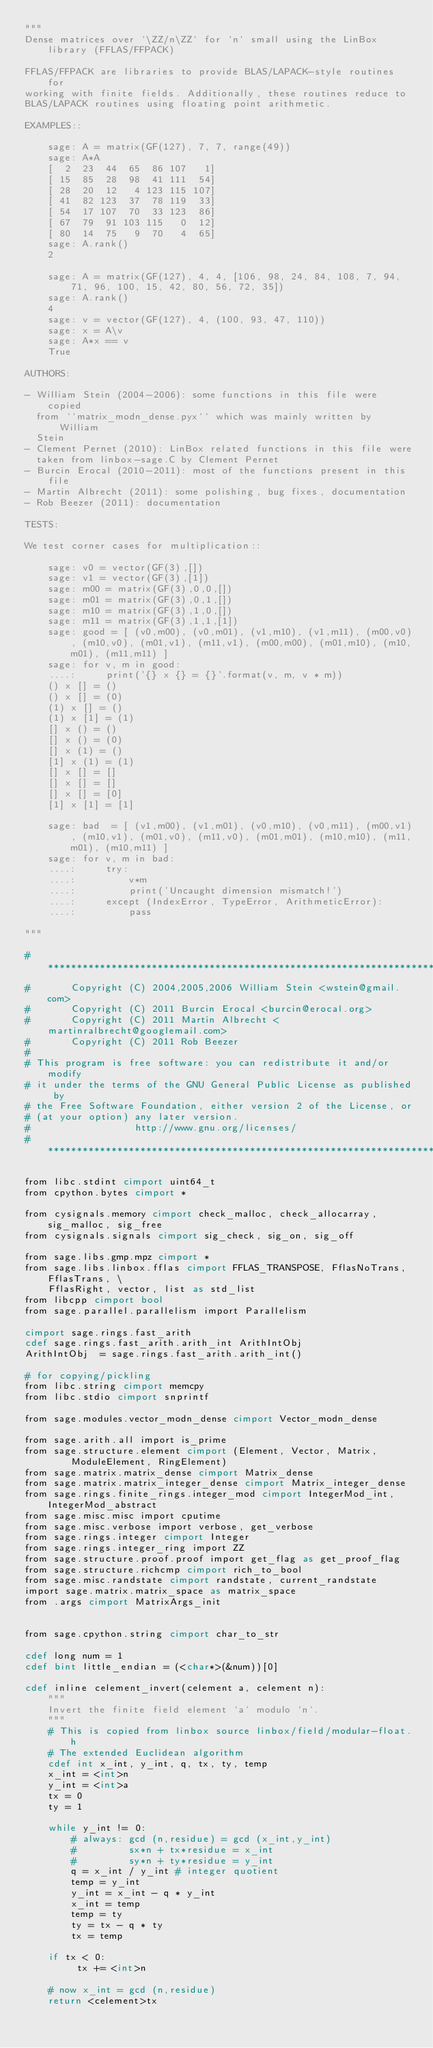<code> <loc_0><loc_0><loc_500><loc_500><_Cython_>"""
Dense matrices over `\ZZ/n\ZZ` for `n` small using the LinBox library (FFLAS/FFPACK)

FFLAS/FFPACK are libraries to provide BLAS/LAPACK-style routines for
working with finite fields. Additionally, these routines reduce to
BLAS/LAPACK routines using floating point arithmetic.

EXAMPLES::

    sage: A = matrix(GF(127), 7, 7, range(49))
    sage: A*A
    [  2  23  44  65  86 107   1]
    [ 15  85  28  98  41 111  54]
    [ 28  20  12   4 123 115 107]
    [ 41  82 123  37  78 119  33]
    [ 54  17 107  70  33 123  86]
    [ 67  79  91 103 115   0  12]
    [ 80  14  75   9  70   4  65]
    sage: A.rank()
    2

    sage: A = matrix(GF(127), 4, 4, [106, 98, 24, 84, 108, 7, 94, 71, 96, 100, 15, 42, 80, 56, 72, 35])
    sage: A.rank()
    4
    sage: v = vector(GF(127), 4, (100, 93, 47, 110))
    sage: x = A\v
    sage: A*x == v
    True

AUTHORS:

- William Stein (2004-2006): some functions in this file were copied
  from ``matrix_modn_dense.pyx`` which was mainly written by William
  Stein
- Clement Pernet (2010): LinBox related functions in this file were
  taken from linbox-sage.C by Clement Pernet
- Burcin Erocal (2010-2011): most of the functions present in this file
- Martin Albrecht (2011): some polishing, bug fixes, documentation
- Rob Beezer (2011): documentation

TESTS:

We test corner cases for multiplication::

    sage: v0 = vector(GF(3),[])
    sage: v1 = vector(GF(3),[1])
    sage: m00 = matrix(GF(3),0,0,[])
    sage: m01 = matrix(GF(3),0,1,[])
    sage: m10 = matrix(GF(3),1,0,[])
    sage: m11 = matrix(GF(3),1,1,[1])
    sage: good = [ (v0,m00), (v0,m01), (v1,m10), (v1,m11), (m00,v0), (m10,v0), (m01,v1), (m11,v1), (m00,m00), (m01,m10), (m10,m01), (m11,m11) ]
    sage: for v, m in good:
    ....:     print('{} x {} = {}'.format(v, m, v * m))
    () x [] = ()
    () x [] = (0)
    (1) x [] = ()
    (1) x [1] = (1)
    [] x () = ()
    [] x () = (0)
    [] x (1) = ()
    [1] x (1) = (1)
    [] x [] = []
    [] x [] = []
    [] x [] = [0]
    [1] x [1] = [1]

    sage: bad  = [ (v1,m00), (v1,m01), (v0,m10), (v0,m11), (m00,v1), (m10,v1), (m01,v0), (m11,v0), (m01,m01), (m10,m10), (m11,m01), (m10,m11) ]
    sage: for v, m in bad:
    ....:     try:
    ....:         v*m
    ....:         print('Uncaught dimension mismatch!')
    ....:     except (IndexError, TypeError, ArithmeticError):
    ....:         pass

"""

#*****************************************************************************
#       Copyright (C) 2004,2005,2006 William Stein <wstein@gmail.com>
#       Copyright (C) 2011 Burcin Erocal <burcin@erocal.org>
#       Copyright (C) 2011 Martin Albrecht <martinralbrecht@googlemail.com>
#       Copyright (C) 2011 Rob Beezer
#
# This program is free software: you can redistribute it and/or modify
# it under the terms of the GNU General Public License as published by
# the Free Software Foundation, either version 2 of the License, or
# (at your option) any later version.
#                  http://www.gnu.org/licenses/
#*****************************************************************************

from libc.stdint cimport uint64_t
from cpython.bytes cimport *

from cysignals.memory cimport check_malloc, check_allocarray, sig_malloc, sig_free
from cysignals.signals cimport sig_check, sig_on, sig_off

from sage.libs.gmp.mpz cimport *
from sage.libs.linbox.fflas cimport FFLAS_TRANSPOSE, FflasNoTrans, FflasTrans, \
    FflasRight, vector, list as std_list
from libcpp cimport bool
from sage.parallel.parallelism import Parallelism

cimport sage.rings.fast_arith
cdef sage.rings.fast_arith.arith_int ArithIntObj
ArithIntObj  = sage.rings.fast_arith.arith_int()

# for copying/pickling
from libc.string cimport memcpy
from libc.stdio cimport snprintf

from sage.modules.vector_modn_dense cimport Vector_modn_dense

from sage.arith.all import is_prime
from sage.structure.element cimport (Element, Vector, Matrix,
        ModuleElement, RingElement)
from sage.matrix.matrix_dense cimport Matrix_dense
from sage.matrix.matrix_integer_dense cimport Matrix_integer_dense
from sage.rings.finite_rings.integer_mod cimport IntegerMod_int, IntegerMod_abstract
from sage.misc.misc import cputime
from sage.misc.verbose import verbose, get_verbose
from sage.rings.integer cimport Integer
from sage.rings.integer_ring import ZZ
from sage.structure.proof.proof import get_flag as get_proof_flag
from sage.structure.richcmp cimport rich_to_bool
from sage.misc.randstate cimport randstate, current_randstate
import sage.matrix.matrix_space as matrix_space
from .args cimport MatrixArgs_init


from sage.cpython.string cimport char_to_str

cdef long num = 1
cdef bint little_endian = (<char*>(&num))[0]

cdef inline celement_invert(celement a, celement n):
    """
    Invert the finite field element `a` modulo `n`.
    """
    # This is copied from linbox source linbox/field/modular-float.h
    # The extended Euclidean algorithm
    cdef int x_int, y_int, q, tx, ty, temp
    x_int = <int>n
    y_int = <int>a
    tx = 0
    ty = 1

    while y_int != 0:
        # always: gcd (n,residue) = gcd (x_int,y_int)
        #         sx*n + tx*residue = x_int
        #         sy*n + ty*residue = y_int
        q = x_int / y_int # integer quotient
        temp = y_int
        y_int = x_int - q * y_int
        x_int = temp
        temp = ty
        ty = tx - q * ty
        tx = temp

    if tx < 0:
         tx += <int>n

    # now x_int = gcd (n,residue)
    return <celement>tx
</code> 